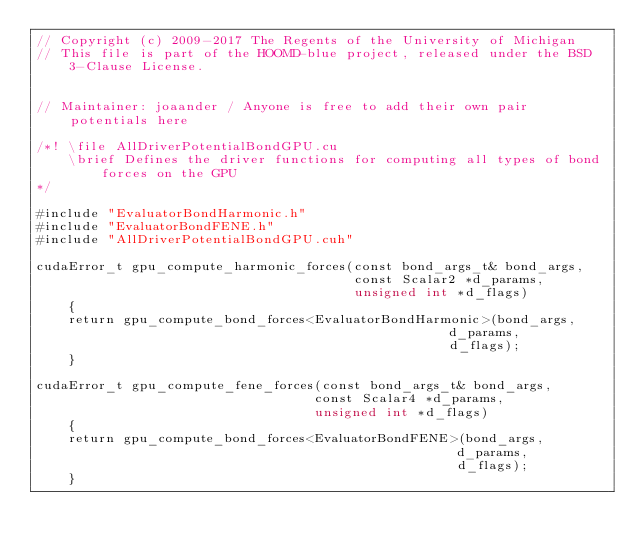<code> <loc_0><loc_0><loc_500><loc_500><_Cuda_>// Copyright (c) 2009-2017 The Regents of the University of Michigan
// This file is part of the HOOMD-blue project, released under the BSD 3-Clause License.


// Maintainer: joaander / Anyone is free to add their own pair potentials here

/*! \file AllDriverPotentialBondGPU.cu
    \brief Defines the driver functions for computing all types of bond forces on the GPU
*/

#include "EvaluatorBondHarmonic.h"
#include "EvaluatorBondFENE.h"
#include "AllDriverPotentialBondGPU.cuh"

cudaError_t gpu_compute_harmonic_forces(const bond_args_t& bond_args,
                                        const Scalar2 *d_params,
                                        unsigned int *d_flags)
    {
    return gpu_compute_bond_forces<EvaluatorBondHarmonic>(bond_args,
                                                    d_params,
                                                    d_flags);
    }

cudaError_t gpu_compute_fene_forces(const bond_args_t& bond_args,
                                   const Scalar4 *d_params,
                                   unsigned int *d_flags)
    {
    return gpu_compute_bond_forces<EvaluatorBondFENE>(bond_args,
                                                     d_params,
                                                     d_flags);
    }
</code> 